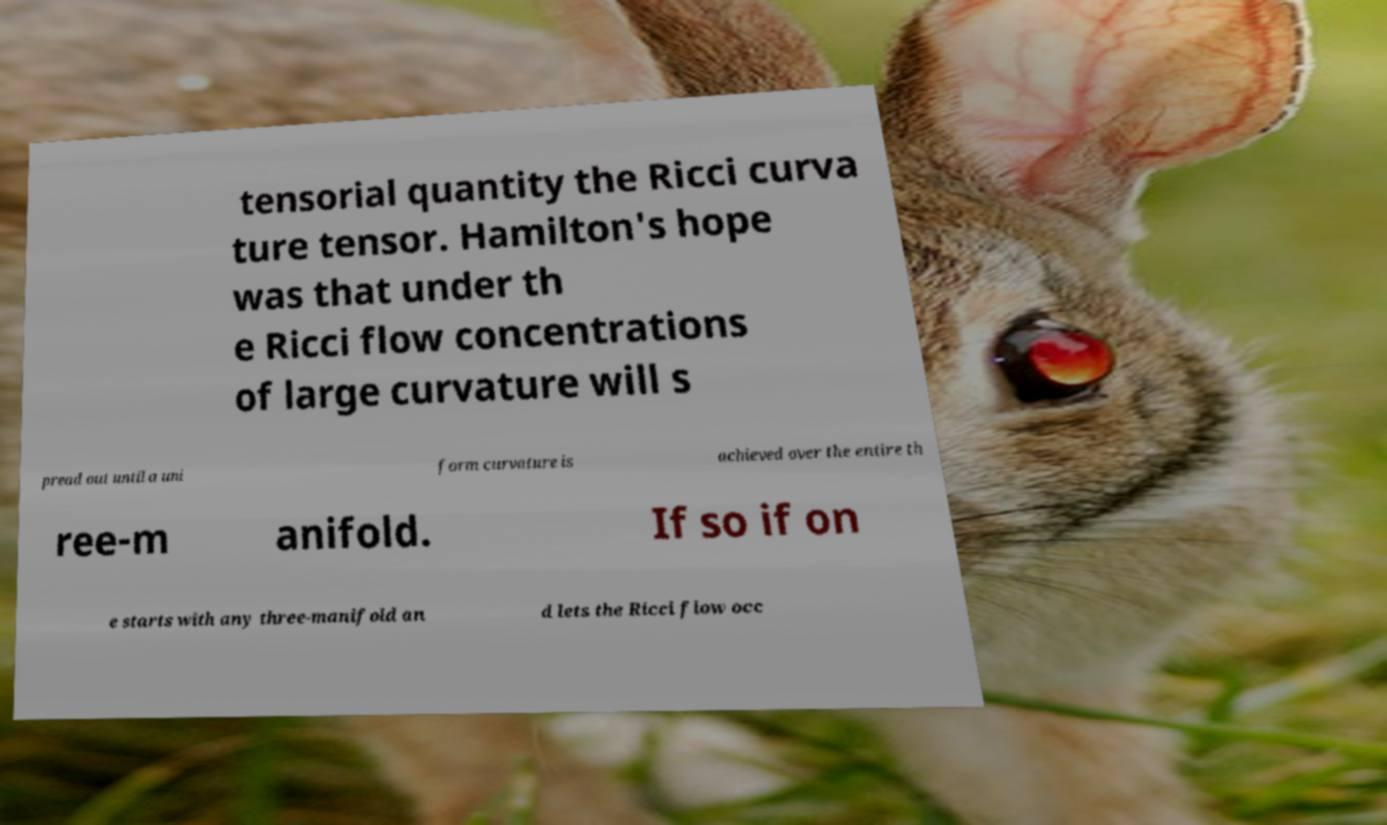Could you extract and type out the text from this image? tensorial quantity the Ricci curva ture tensor. Hamilton's hope was that under th e Ricci flow concentrations of large curvature will s pread out until a uni form curvature is achieved over the entire th ree-m anifold. If so if on e starts with any three-manifold an d lets the Ricci flow occ 